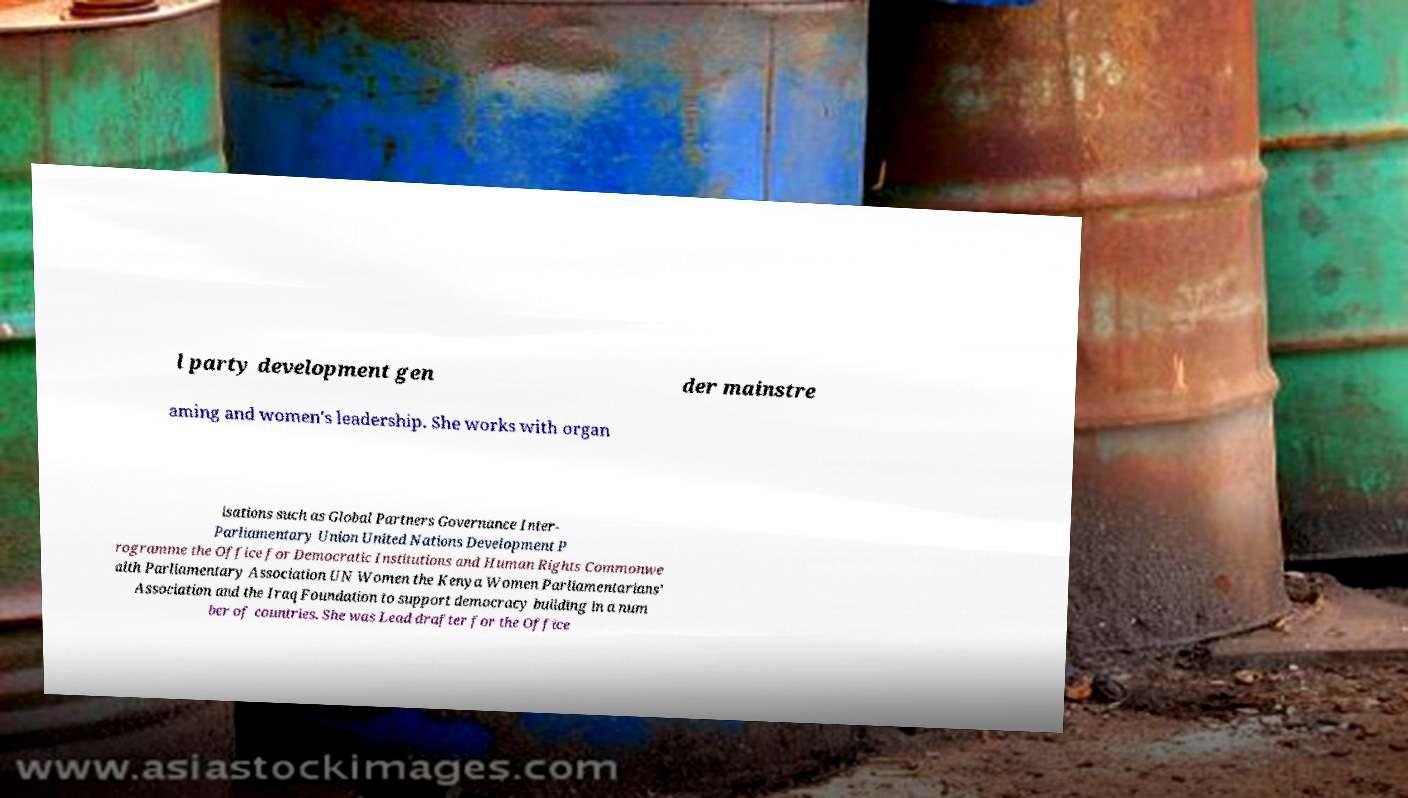Please identify and transcribe the text found in this image. l party development gen der mainstre aming and women's leadership. She works with organ isations such as Global Partners Governance Inter- Parliamentary Union United Nations Development P rogramme the Office for Democratic Institutions and Human Rights Commonwe alth Parliamentary Association UN Women the Kenya Women Parliamentarians’ Association and the Iraq Foundation to support democracy building in a num ber of countries. She was Lead drafter for the Office 